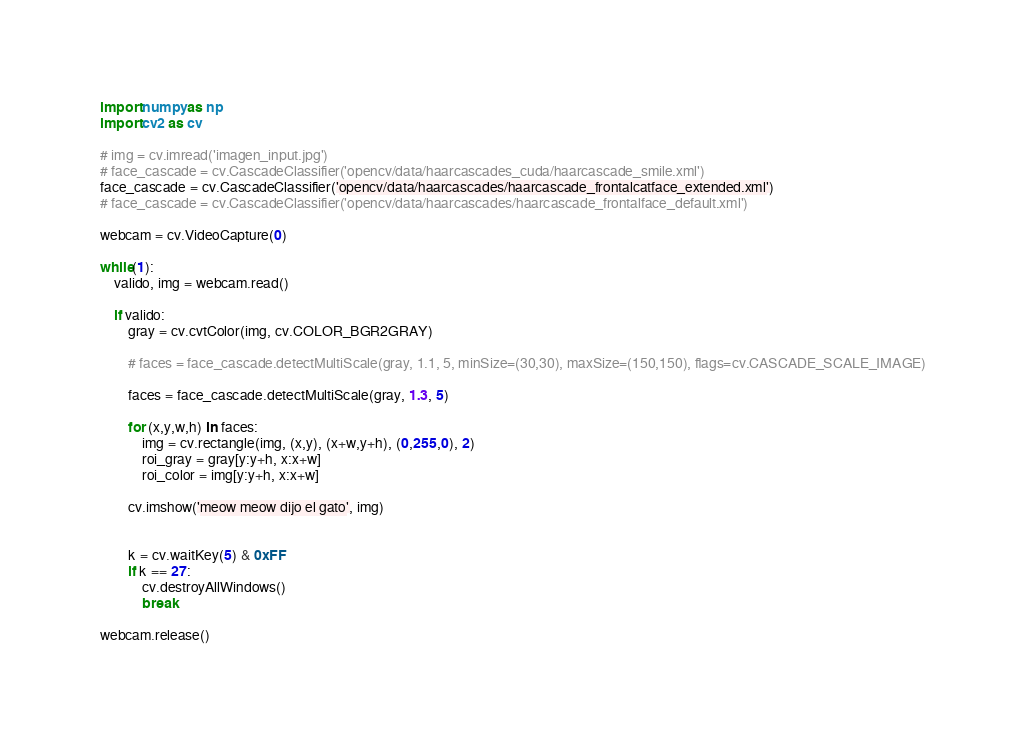Convert code to text. <code><loc_0><loc_0><loc_500><loc_500><_Python_>import numpy as np
import cv2 as cv 

# img = cv.imread('imagen_input.jpg')
# face_cascade = cv.CascadeClassifier('opencv/data/haarcascades_cuda/haarcascade_smile.xml')
face_cascade = cv.CascadeClassifier('opencv/data/haarcascades/haarcascade_frontalcatface_extended.xml')
# face_cascade = cv.CascadeClassifier('opencv/data/haarcascades/haarcascade_frontalface_default.xml')

webcam = cv.VideoCapture(0)

while(1):
    valido, img = webcam.read()

    if valido:
        gray = cv.cvtColor(img, cv.COLOR_BGR2GRAY)

        # faces = face_cascade.detectMultiScale(gray, 1.1, 5, minSize=(30,30), maxSize=(150,150), flags=cv.CASCADE_SCALE_IMAGE)

        faces = face_cascade.detectMultiScale(gray, 1.3, 5)

        for (x,y,w,h) in faces:
            img = cv.rectangle(img, (x,y), (x+w,y+h), (0,255,0), 2)
            roi_gray = gray[y:y+h, x:x+w]
            roi_color = img[y:y+h, x:x+w]

        cv.imshow('meow meow dijo el gato', img)


        k = cv.waitKey(5) & 0xFF
        if k == 27:
            cv.destroyAllWindows()
            break

webcam.release()


</code> 